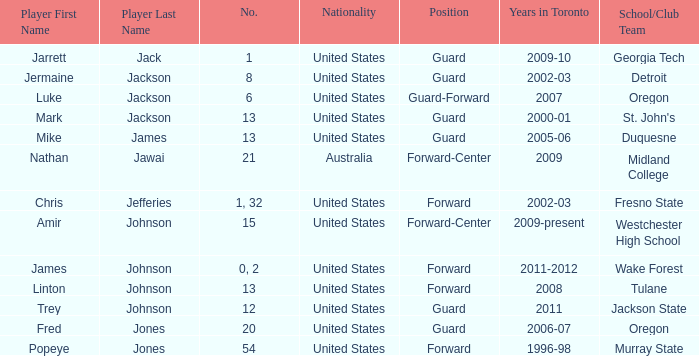What school/club team is Trey Johnson on? Jackson State. 